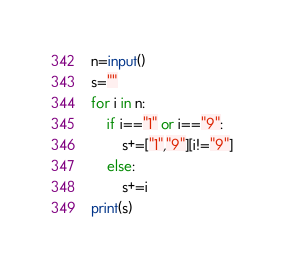Convert code to text. <code><loc_0><loc_0><loc_500><loc_500><_Python_>n=input()
s=""
for i in n:
    if i=="1" or i=="9":
        s+=["1","9"][i!="9"]
    else:
        s+=i
print(s)
</code> 